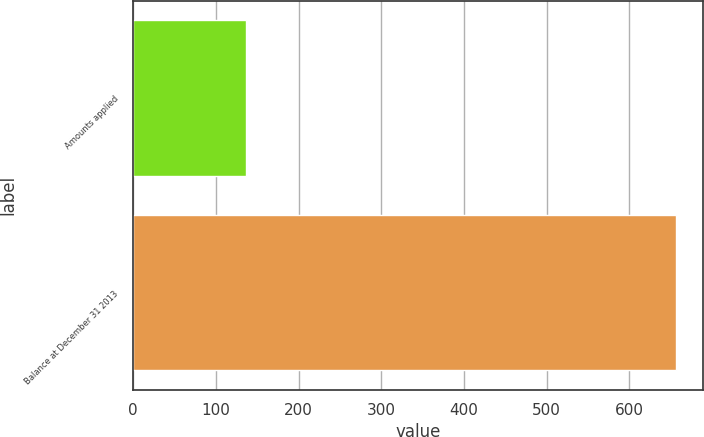<chart> <loc_0><loc_0><loc_500><loc_500><bar_chart><fcel>Amounts applied<fcel>Balance at December 31 2013<nl><fcel>136<fcel>656<nl></chart> 